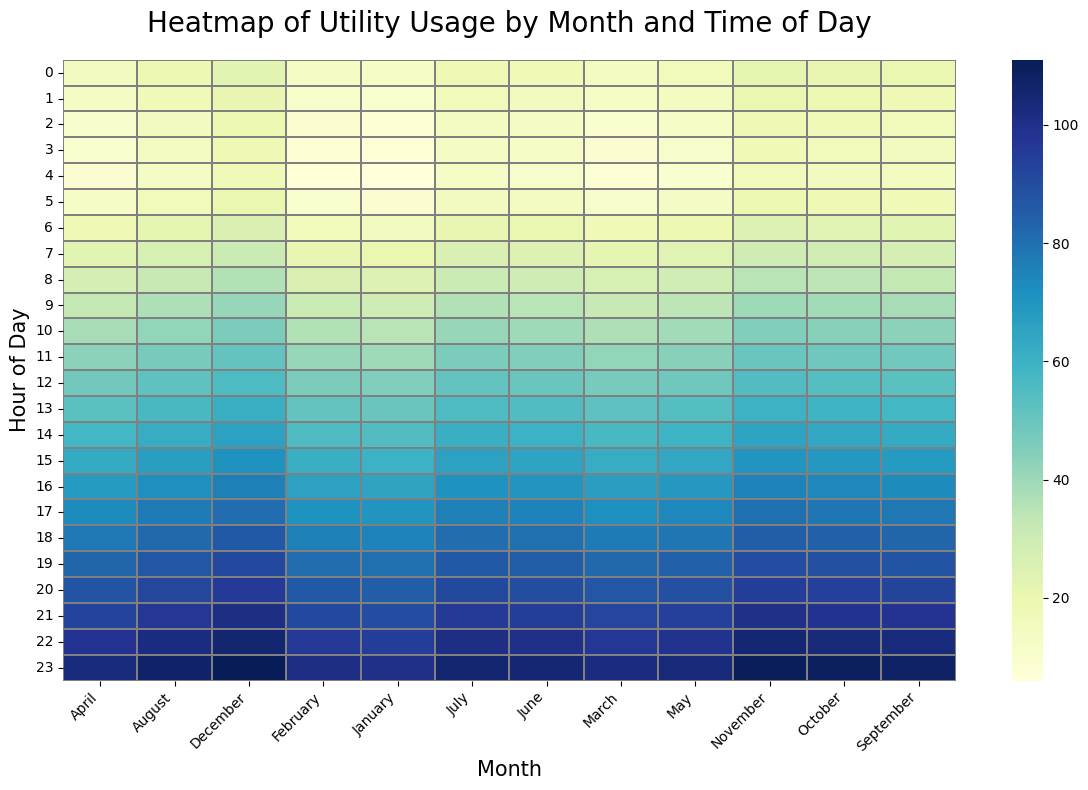What is the hour with the lowest utility usage in January? Look for the lightest (least intense) color in the January column. The lightest color corresponds to the utility usage of 6 at 4 AM in January.
Answer: 4 AM During which month is utility usage highest at 10 PM? Locate the 22nd hour row, then find the month column with the darkest (most intense) color. November has the darkest color at this hour, indicating the highest usage.
Answer: November Compare utility usage at 6 AM between July and November. Which month has higher usage and by how much? Find the 6th hour row and compare the values in the July and November columns. July has 21 and November has 25. Subtract July's usage from November's to get the difference.
Answer: November by 4 What is the average utility usage at midnight (12 AM) across all months? Sum the values at the 0th hour for all months (12 + 13 + 14 + 15 + ... + 23) and divide by 12 (number of months).
Answer: 17.5 Which month shows the greatest increase in utility usage from 2 AM to 3 AM? For each month, find the difference between the usage at 2 AM and 3 AM. Compare these differences to find the largest. March has the largest increase (10 to 9, difference of 1).
Answer: March Identify the time of day when utility usage generally peaks across all months. Look for the consistently darkest color (most intense) across the rows representing hours of the day. The 23rd hour (11 PM) generally has the darkest color.
Answer: 11 PM How do utility usage patterns differ between winter (December to February) and summer (June to August) months? Compare the colors from December to February against June to August. Winter months tend to have lighter colors earlier in the day, while summer months have darker colors throughout.
Answer: Winter lighter early, summer darker throughout Which month has the most consistent utility usage throughout the day, and what is the range of usage in that month? Look for the month column with the least variation in color intensity from top to bottom. April shows minimal variation. The usage ranges from 9 to 103.
Answer: April, range of 94 